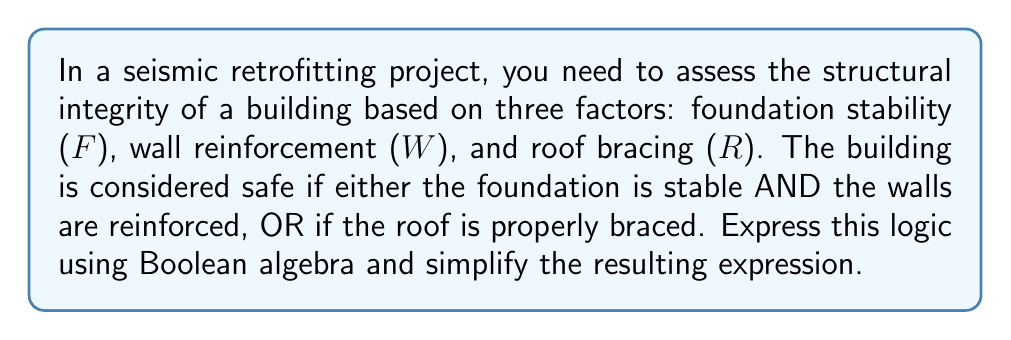What is the answer to this math problem? Let's approach this step-by-step:

1) First, we need to express the given logic in Boolean algebra:
   $$(F \cdot W) + R$$

   Where:
   $F$ = Foundation stability
   $W$ = Wall reinforcement
   $R$ = Roof bracing
   $\cdot$ represents AND
   $+$ represents OR

2) This expression is already relatively simple, but we can apply the distributive law to expand it:
   $$(F \cdot W) + (R \cdot 1)$$

3) The identity property of multiplication states that $x \cdot 1 = x$ for any $x$, so:
   $$(F \cdot W) + R$$

4) This is our final simplified expression. It accurately represents the logic that the building is safe if:
   - The foundation is stable AND the walls are reinforced, OR
   - The roof is properly braced (regardless of the state of the foundation and walls)

5) In terms of structural assessment, this Boolean expression allows for a quick evaluation of safety based on these three key factors, without unnecessary complexity.
Answer: $$(F \cdot W) + R$$ 